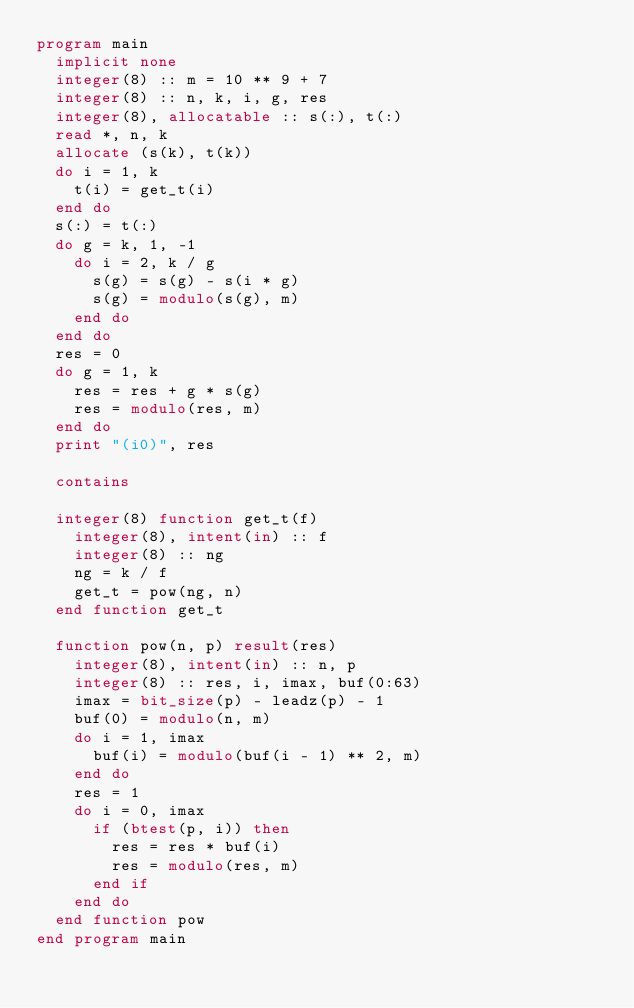<code> <loc_0><loc_0><loc_500><loc_500><_FORTRAN_>program main
  implicit none
  integer(8) :: m = 10 ** 9 + 7
  integer(8) :: n, k, i, g, res
  integer(8), allocatable :: s(:), t(:)
  read *, n, k
  allocate (s(k), t(k))
  do i = 1, k
    t(i) = get_t(i)
  end do
  s(:) = t(:)
  do g = k, 1, -1
    do i = 2, k / g
      s(g) = s(g) - s(i * g)
      s(g) = modulo(s(g), m)
    end do
  end do
  res = 0
  do g = 1, k
    res = res + g * s(g)
    res = modulo(res, m)
  end do
  print "(i0)", res

  contains

  integer(8) function get_t(f)
    integer(8), intent(in) :: f
    integer(8) :: ng
    ng = k / f
    get_t = pow(ng, n)
  end function get_t

  function pow(n, p) result(res)
    integer(8), intent(in) :: n, p
    integer(8) :: res, i, imax, buf(0:63)
    imax = bit_size(p) - leadz(p) - 1
    buf(0) = modulo(n, m)
    do i = 1, imax
      buf(i) = modulo(buf(i - 1) ** 2, m)
    end do
    res = 1
    do i = 0, imax
      if (btest(p, i)) then
        res = res * buf(i)
        res = modulo(res, m)
      end if
    end do
  end function pow
end program main
</code> 